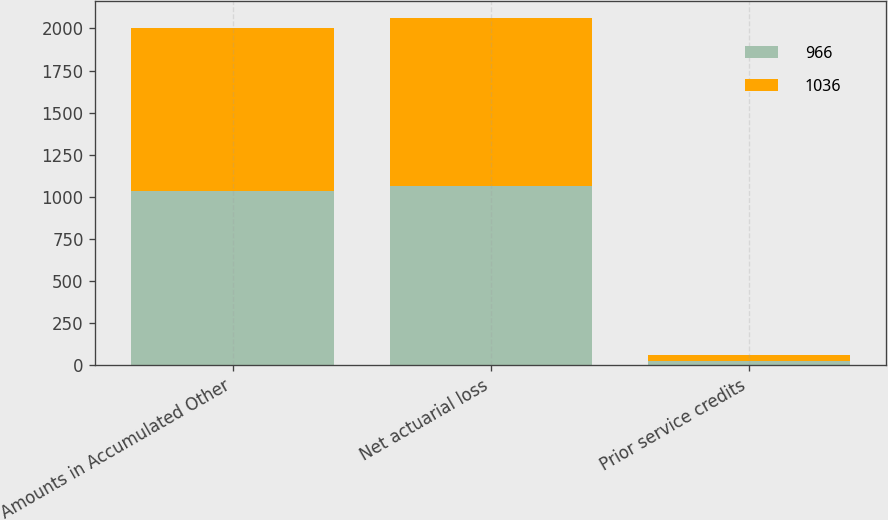Convert chart to OTSL. <chart><loc_0><loc_0><loc_500><loc_500><stacked_bar_chart><ecel><fcel>Amounts in Accumulated Other<fcel>Net actuarial loss<fcel>Prior service credits<nl><fcel>966<fcel>1036<fcel>1060<fcel>24<nl><fcel>1036<fcel>966<fcel>1001<fcel>35<nl></chart> 